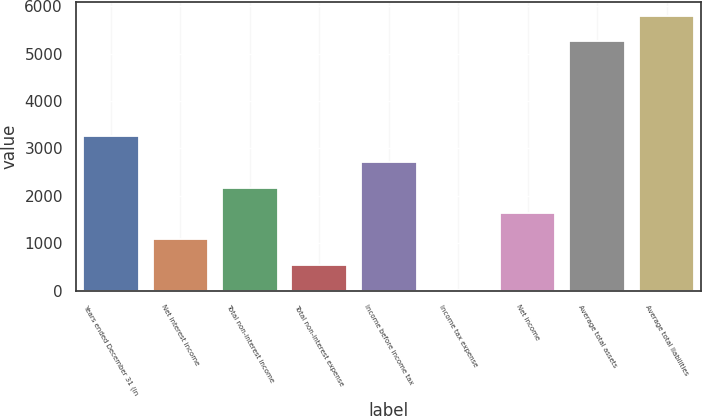Convert chart to OTSL. <chart><loc_0><loc_0><loc_500><loc_500><bar_chart><fcel>Years ended December 31 (in<fcel>Net interest income<fcel>Total non-interest income<fcel>Total non-interest expense<fcel>Income before income tax<fcel>Income tax expense<fcel>Net income<fcel>Average total assets<fcel>Average total liabilities<nl><fcel>3253.12<fcel>1088.24<fcel>2170.68<fcel>547.02<fcel>2711.9<fcel>5.8<fcel>1629.46<fcel>5261.2<fcel>5802.42<nl></chart> 